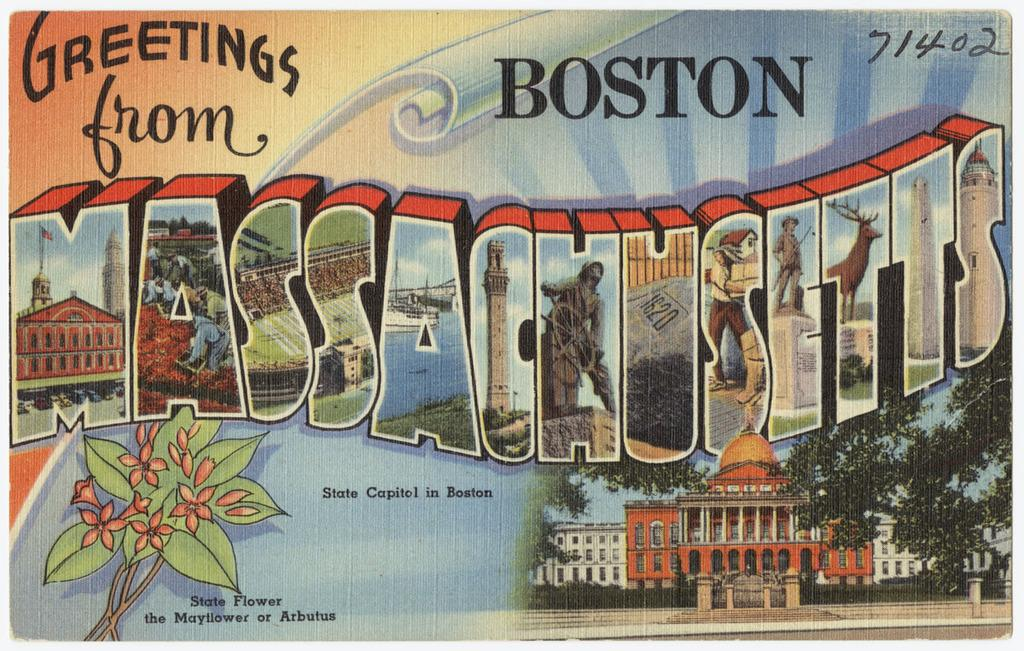Provide a one-sentence caption for the provided image. The greetings card is clearly from the state of Boston. 